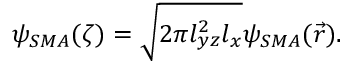<formula> <loc_0><loc_0><loc_500><loc_500>\psi _ { S M A } ( \zeta ) = \sqrt { 2 \pi l _ { y z } ^ { 2 } l _ { x } } \psi _ { S M A } ( \vec { r } ) .</formula> 